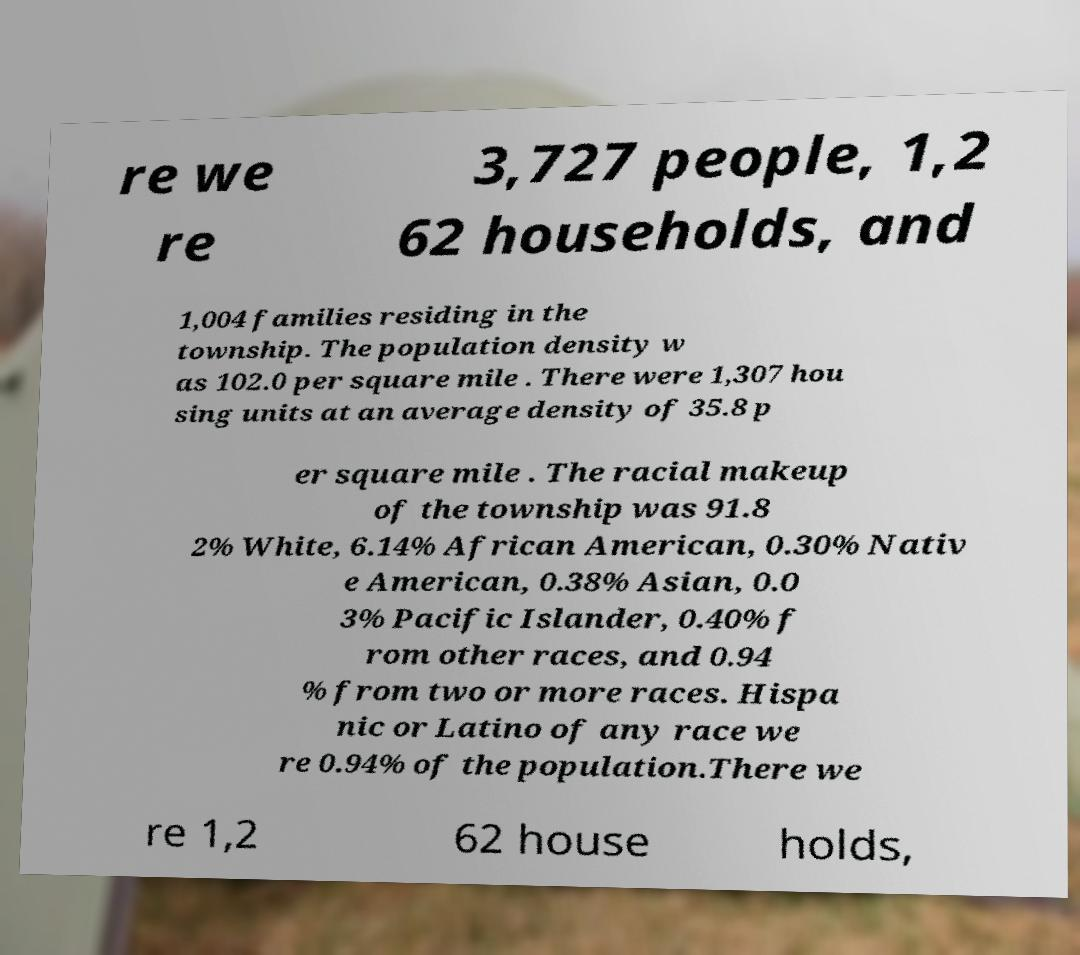Can you read and provide the text displayed in the image?This photo seems to have some interesting text. Can you extract and type it out for me? re we re 3,727 people, 1,2 62 households, and 1,004 families residing in the township. The population density w as 102.0 per square mile . There were 1,307 hou sing units at an average density of 35.8 p er square mile . The racial makeup of the township was 91.8 2% White, 6.14% African American, 0.30% Nativ e American, 0.38% Asian, 0.0 3% Pacific Islander, 0.40% f rom other races, and 0.94 % from two or more races. Hispa nic or Latino of any race we re 0.94% of the population.There we re 1,2 62 house holds, 